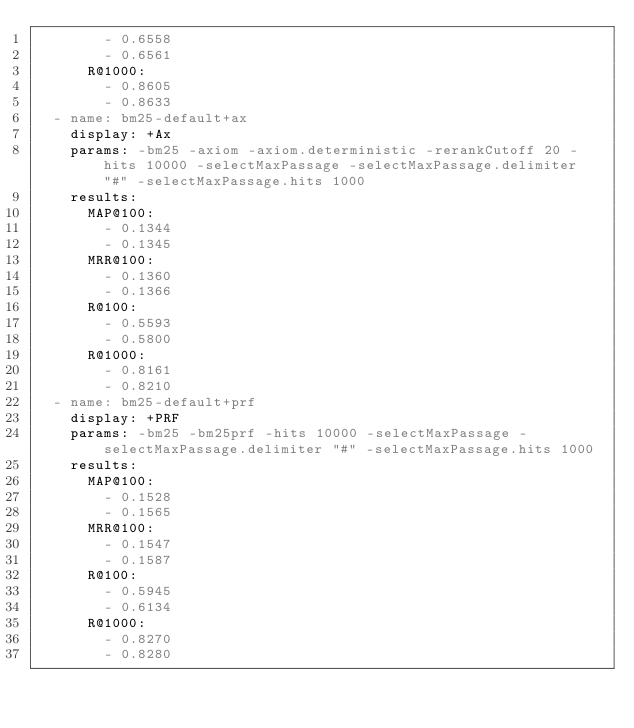Convert code to text. <code><loc_0><loc_0><loc_500><loc_500><_YAML_>        - 0.6558
        - 0.6561
      R@1000:
        - 0.8605
        - 0.8633
  - name: bm25-default+ax
    display: +Ax
    params: -bm25 -axiom -axiom.deterministic -rerankCutoff 20 -hits 10000 -selectMaxPassage -selectMaxPassage.delimiter "#" -selectMaxPassage.hits 1000
    results:
      MAP@100:
        - 0.1344
        - 0.1345
      MRR@100:
        - 0.1360
        - 0.1366
      R@100:
        - 0.5593
        - 0.5800
      R@1000:
        - 0.8161
        - 0.8210
  - name: bm25-default+prf
    display: +PRF
    params: -bm25 -bm25prf -hits 10000 -selectMaxPassage -selectMaxPassage.delimiter "#" -selectMaxPassage.hits 1000
    results:
      MAP@100:
        - 0.1528
        - 0.1565
      MRR@100:
        - 0.1547
        - 0.1587
      R@100:
        - 0.5945
        - 0.6134
      R@1000:
        - 0.8270
        - 0.8280
</code> 